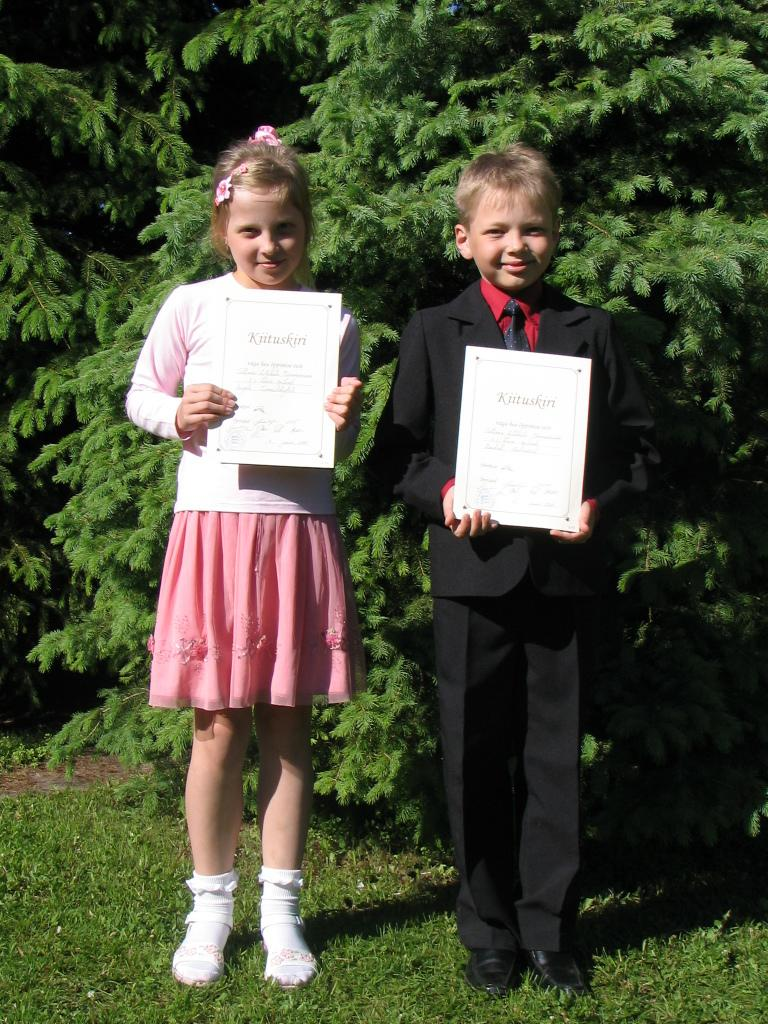How many children are in the image? There are two children in the image. What are the children doing in the image? The children are standing on the grass and holding a poster with text on it. What can be seen in the background of the image? There are trees visible in the background of the image. What color is the eye of the thunder in the image? There is no thunder or eye present in the image. 